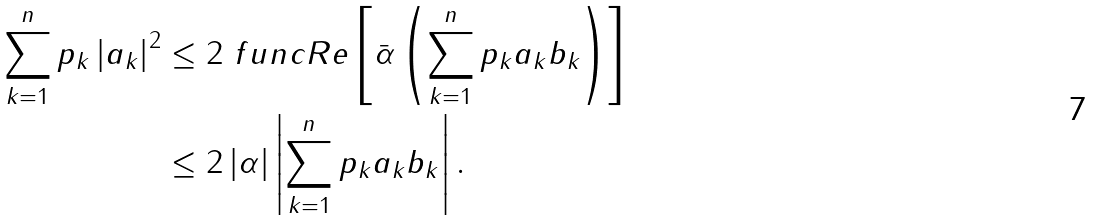Convert formula to latex. <formula><loc_0><loc_0><loc_500><loc_500>\sum _ { k = 1 } ^ { n } p _ { k } \left | a _ { k } \right | ^ { 2 } & \leq 2 \ f u n c { R e } \left [ \bar { \alpha } \left ( \sum _ { k = 1 } ^ { n } p _ { k } a _ { k } b _ { k } \right ) \right ] \\ & \leq 2 \left | \alpha \right | \left | \sum _ { k = 1 } ^ { n } p _ { k } a _ { k } b _ { k } \right | .</formula> 